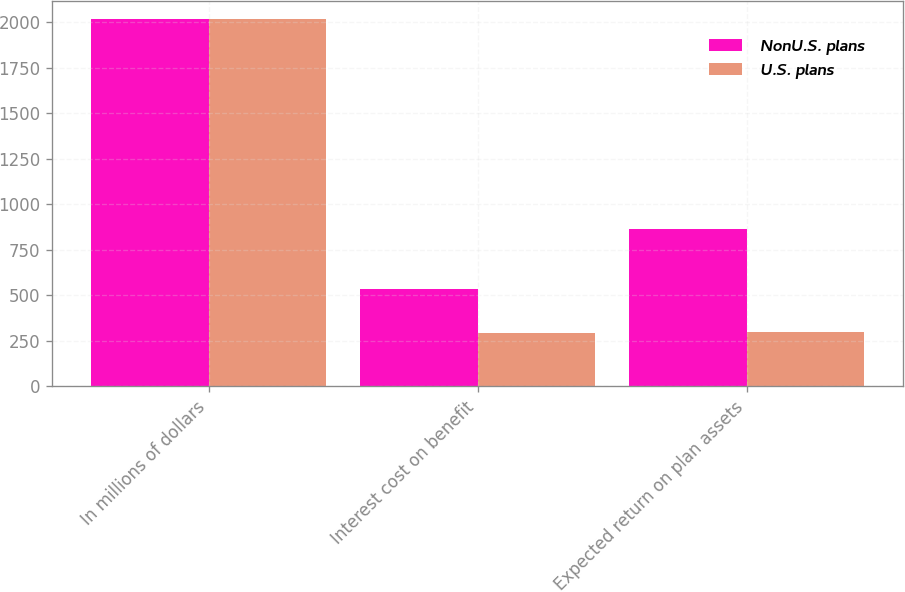Convert chart to OTSL. <chart><loc_0><loc_0><loc_500><loc_500><stacked_bar_chart><ecel><fcel>In millions of dollars<fcel>Interest cost on benefit<fcel>Expected return on plan assets<nl><fcel>NonU.S. plans<fcel>2017<fcel>533<fcel>865<nl><fcel>U.S. plans<fcel>2017<fcel>295<fcel>299<nl></chart> 